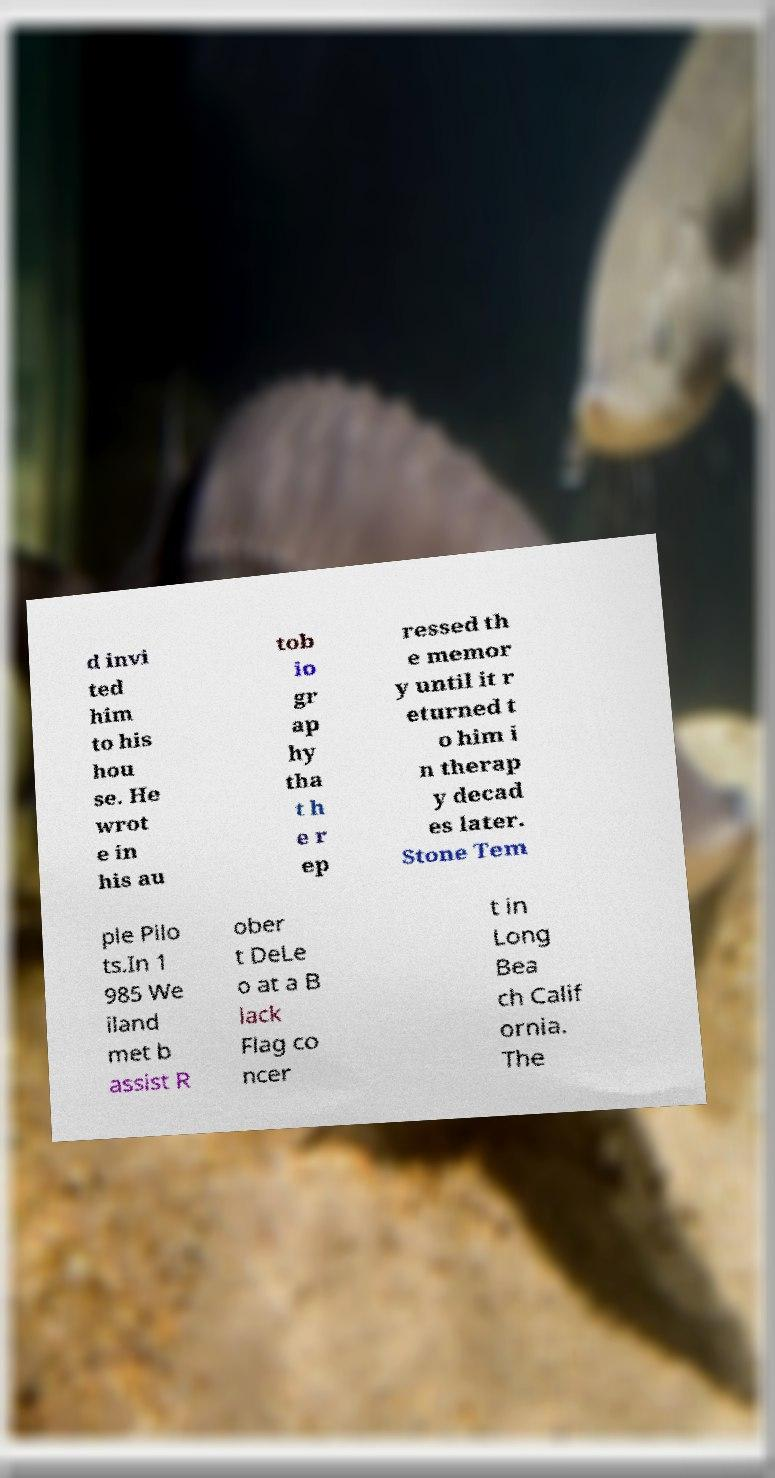Please read and relay the text visible in this image. What does it say? d invi ted him to his hou se. He wrot e in his au tob io gr ap hy tha t h e r ep ressed th e memor y until it r eturned t o him i n therap y decad es later. Stone Tem ple Pilo ts.In 1 985 We iland met b assist R ober t DeLe o at a B lack Flag co ncer t in Long Bea ch Calif ornia. The 